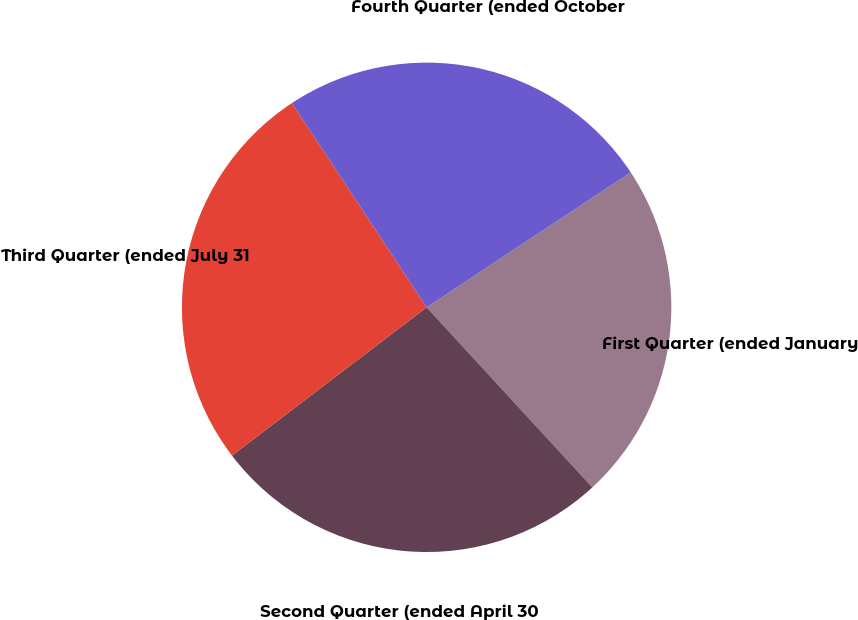Convert chart. <chart><loc_0><loc_0><loc_500><loc_500><pie_chart><fcel>First Quarter (ended January<fcel>Second Quarter (ended April 30<fcel>Third Quarter (ended July 31<fcel>Fourth Quarter (ended October<nl><fcel>22.46%<fcel>26.48%<fcel>26.08%<fcel>24.98%<nl></chart> 